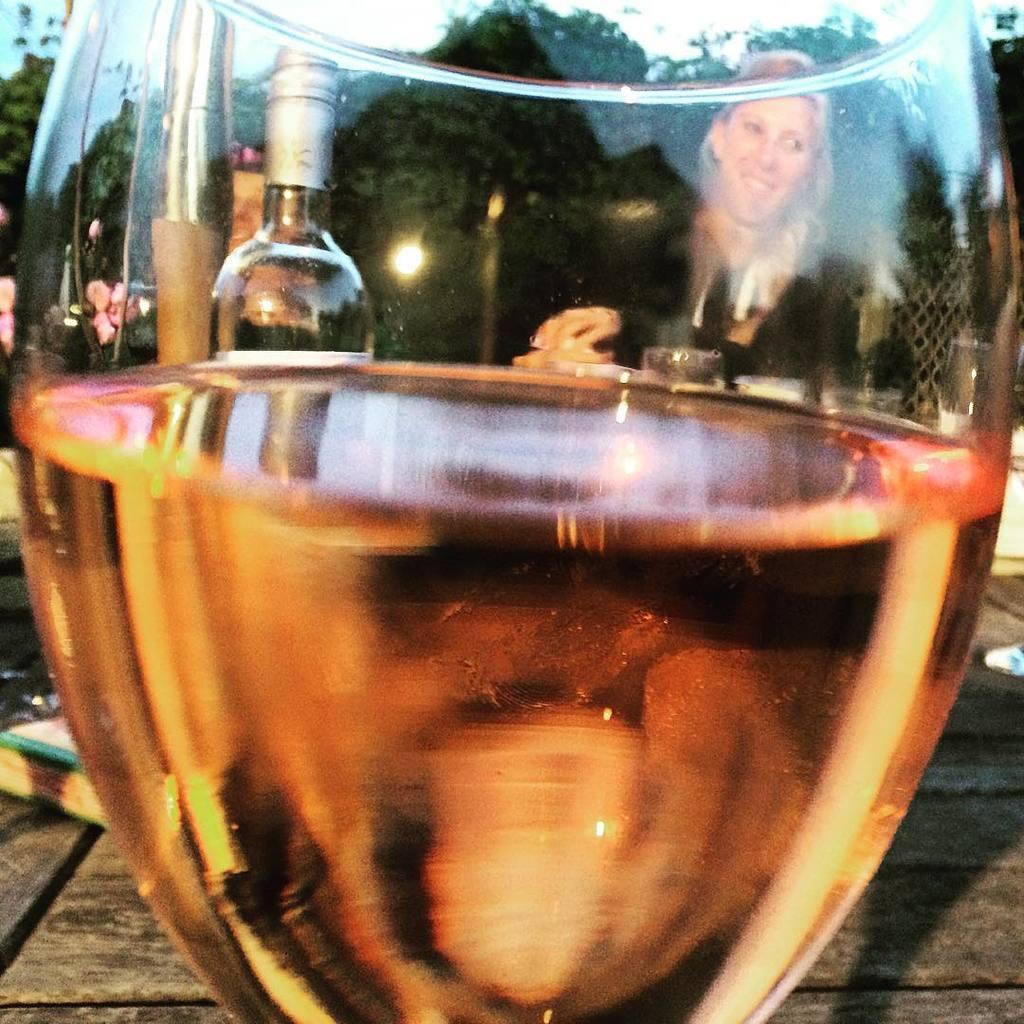In one or two sentences, can you explain what this image depicts? This picture shows a woman seated and we see a wine glass and few wine bottles on the table 